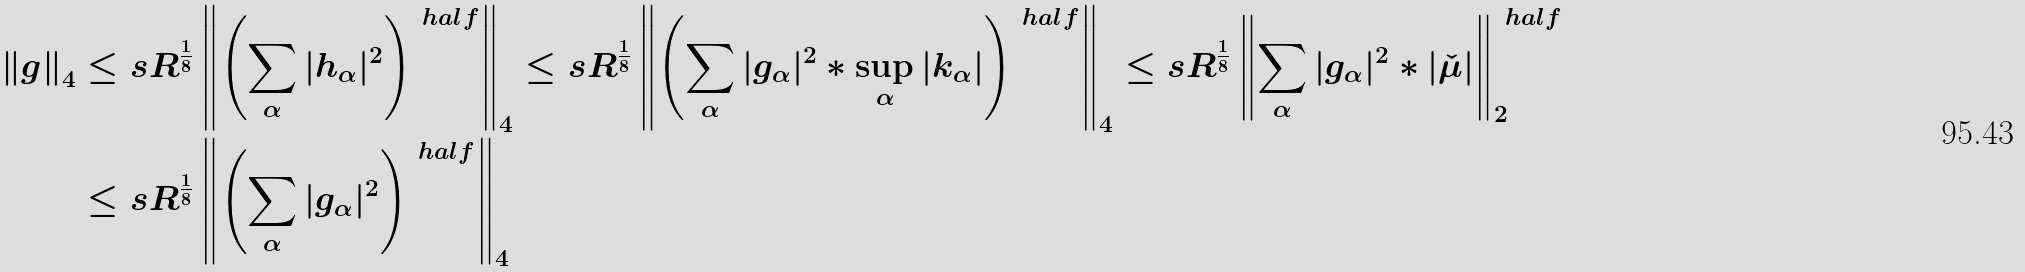<formula> <loc_0><loc_0><loc_500><loc_500>\left \| g \right \| _ { 4 } & \leq s R ^ { \frac { 1 } { 8 } } \left \| \left ( \sum _ { \alpha } | h _ { \alpha } | ^ { 2 } \right ) ^ { \ h a l f } \right \| _ { 4 } \leq s R ^ { \frac { 1 } { 8 } } \left \| \left ( \sum _ { \alpha } | g _ { \alpha } | ^ { 2 } \ast \sup _ { \alpha } | k _ { \alpha } | \right ) ^ { \ h a l f } \right \| _ { 4 } \leq s R ^ { \frac { 1 } { 8 } } \left \| \sum _ { \alpha } | g _ { \alpha } | ^ { 2 } \ast | \check { \mu } | \right \| _ { 2 } ^ { \ h a l f } \\ & \leq s R ^ { \frac { 1 } { 8 } } \left \| \left ( \sum _ { \alpha } | g _ { \alpha } | ^ { 2 } \right ) ^ { \ h a l f } \right \| _ { 4 }</formula> 